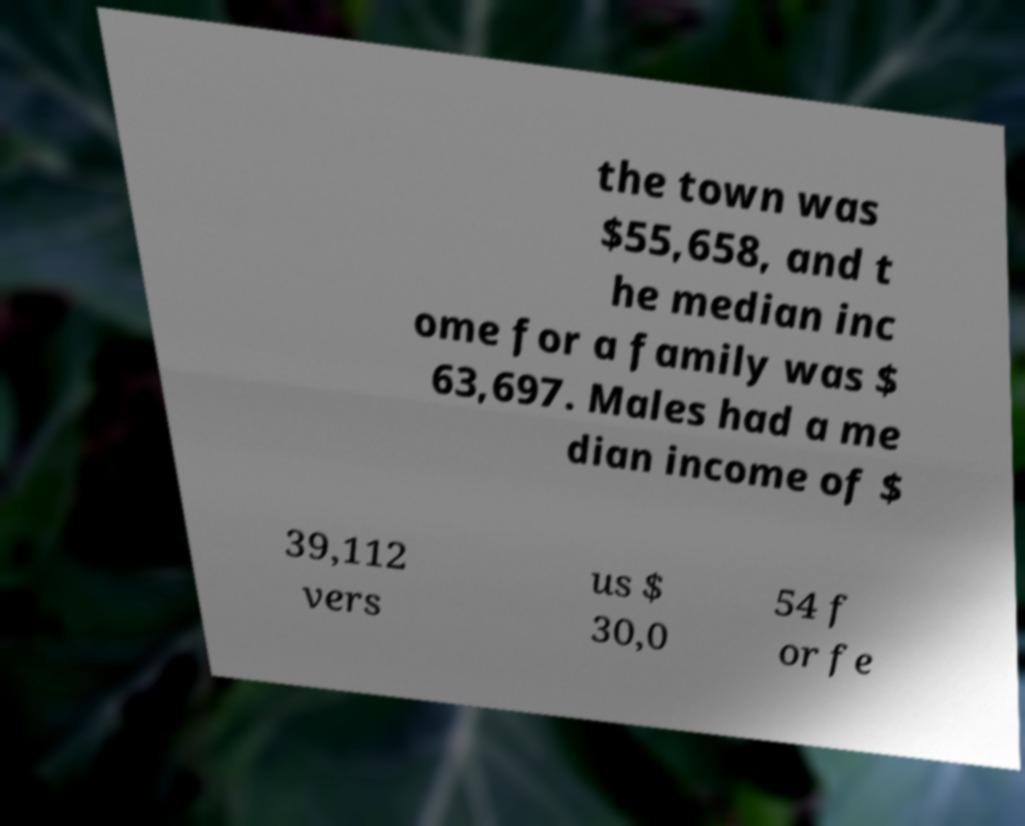Can you read and provide the text displayed in the image?This photo seems to have some interesting text. Can you extract and type it out for me? the town was $55,658, and t he median inc ome for a family was $ 63,697. Males had a me dian income of $ 39,112 vers us $ 30,0 54 f or fe 